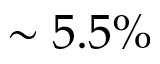<formula> <loc_0><loc_0><loc_500><loc_500>\sim 5 . 5 \%</formula> 